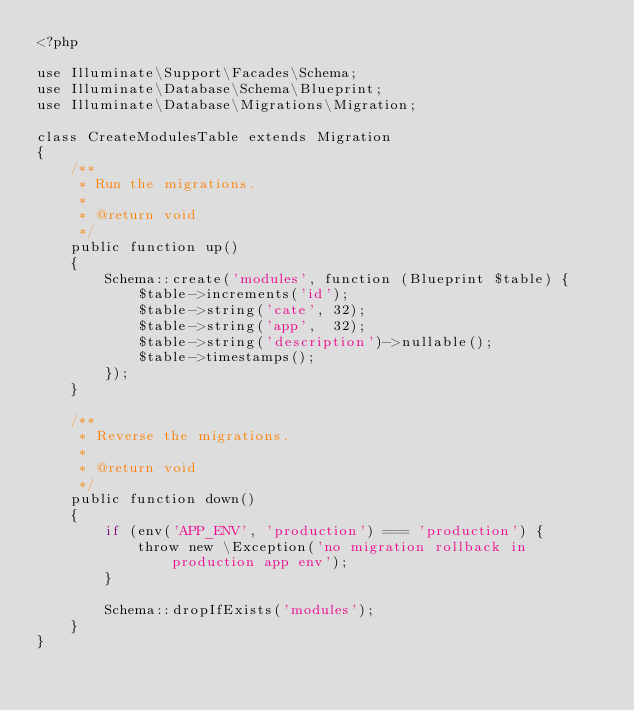Convert code to text. <code><loc_0><loc_0><loc_500><loc_500><_PHP_><?php

use Illuminate\Support\Facades\Schema;
use Illuminate\Database\Schema\Blueprint;
use Illuminate\Database\Migrations\Migration;

class CreateModulesTable extends Migration
{
    /**
     * Run the migrations.
     *
     * @return void
     */
    public function up()
    {
        Schema::create('modules', function (Blueprint $table) {
            $table->increments('id');
            $table->string('cate', 32);
            $table->string('app',  32);
            $table->string('description')->nullable();
            $table->timestamps();
        });
    }

    /**
     * Reverse the migrations.
     *
     * @return void
     */
    public function down()
    {
        if (env('APP_ENV', 'production') === 'production') {
            throw new \Exception('no migration rollback in production app env');
        }
        
        Schema::dropIfExists('modules');
    }
}
</code> 